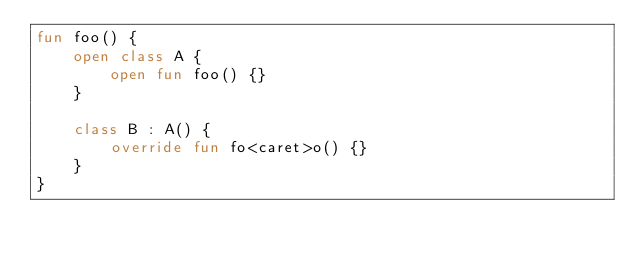<code> <loc_0><loc_0><loc_500><loc_500><_Kotlin_>fun foo() {
    open class A {
        open fun foo() {}
    }

    class B : A() {
        override fun fo<caret>o() {}
    }
}</code> 